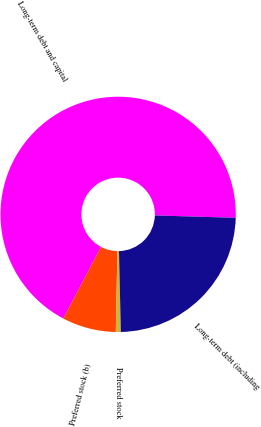Convert chart. <chart><loc_0><loc_0><loc_500><loc_500><pie_chart><fcel>Long-term debt and capital<fcel>Preferred stock (b)<fcel>Preferred stock<fcel>Long-term debt (including<nl><fcel>67.76%<fcel>7.39%<fcel>0.68%<fcel>24.17%<nl></chart> 